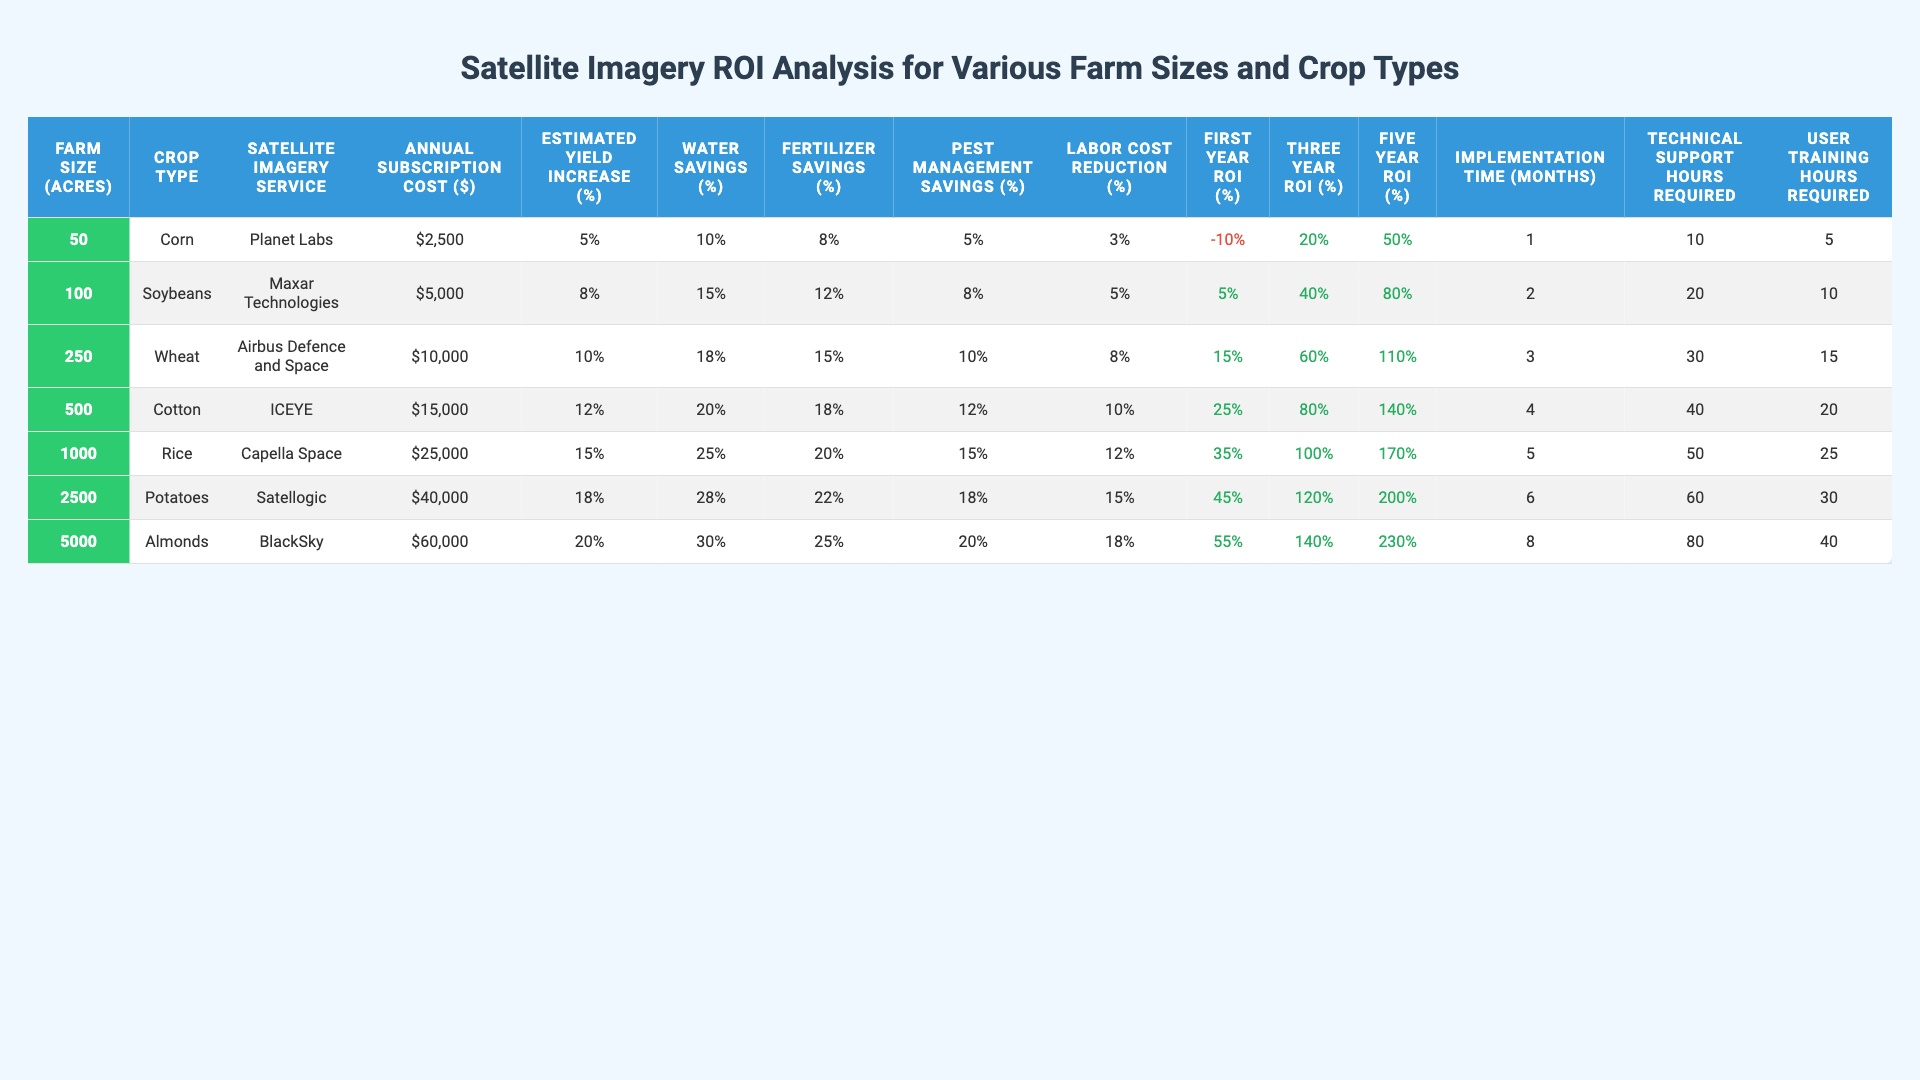What is the annual subscription cost for satellite imagery services for a 100-acre farm? The table lists the annual subscription cost for each farm size. For a 100-acre farm, the cost is shown in the relevant row under the "Annual Subscription Cost ($)" column, which displays $5,000.
Answer: $5,000 Which crop type has the highest estimated yield increase percentage? By looking at the "Estimated Yield Increase (%)" column, the maximum value found is 20%, which corresponds to the crop type "Almonds".
Answer: Almonds What is the first-year ROI for using Maxar Technologies on a 100-acre farm? The first-year ROI for Maxar Technologies can be found in the corresponding row for the 100-acre farm. It shows 5% under the "First Year ROI (%)" column.
Answer: 5% How does the five-year ROI for a 250-acre farm compare to that of a 500-acre farm? The five-year ROI for a 250-acre farm is 110%, and for a 500-acre farm, it is 140%. The difference between these values is 140% - 110% = 30%, indicating that the ROI for a 500-acre farm is 30% higher.
Answer: 30% Is there a farm size where the first-year ROI is negative? Looking at the first-year ROI column, the only negative value is shown for a 50-acre farm, indicating that this is true for that farm size.
Answer: Yes What is the average implementation time (in months) for all farm sizes listed? To calculate the average, sum the implementation times: 1 + 2 + 3 + 4 + 5 + 6 + 8 = 29 months. There are 7 farm sizes, so the average is 29/7 = 4.14 months, approximately.
Answer: 4.14 months For how many crop types does the pest management savings exceed 10%? By examining the "Pest Management Savings (%)" column, the values greater than 10% are for Cotton (12%), Rice (15%), Potatoes (18%), and Almonds (20%). This gives a total of 4 crop types.
Answer: 4 What is the correlation between farm size and five-year ROI? As farm size increases, the five-year ROI also increases: 50 acres = 50%, 100 acres = 80%, and so on, with the highest value being 230% for 5000 acres. This indicates a positive correlation.
Answer: Positive correlation How many technical support hours are required for using ICEYE on a 500-acre farm? Referring to the table, the technical support hours required for ICEYE on a 500-acre farm is 40 hours, as indicated in the relevant row under the "Technical Support Hours Required" column.
Answer: 40 hours What is the percentage difference in water savings between the 100-acre farm and the 250-acre farm? The water savings for the 100-acre farm is 15%, while for the 250-acre farm it is 18%. The percentage difference can be calculated as 18% - 15% = 3%.
Answer: 3% 